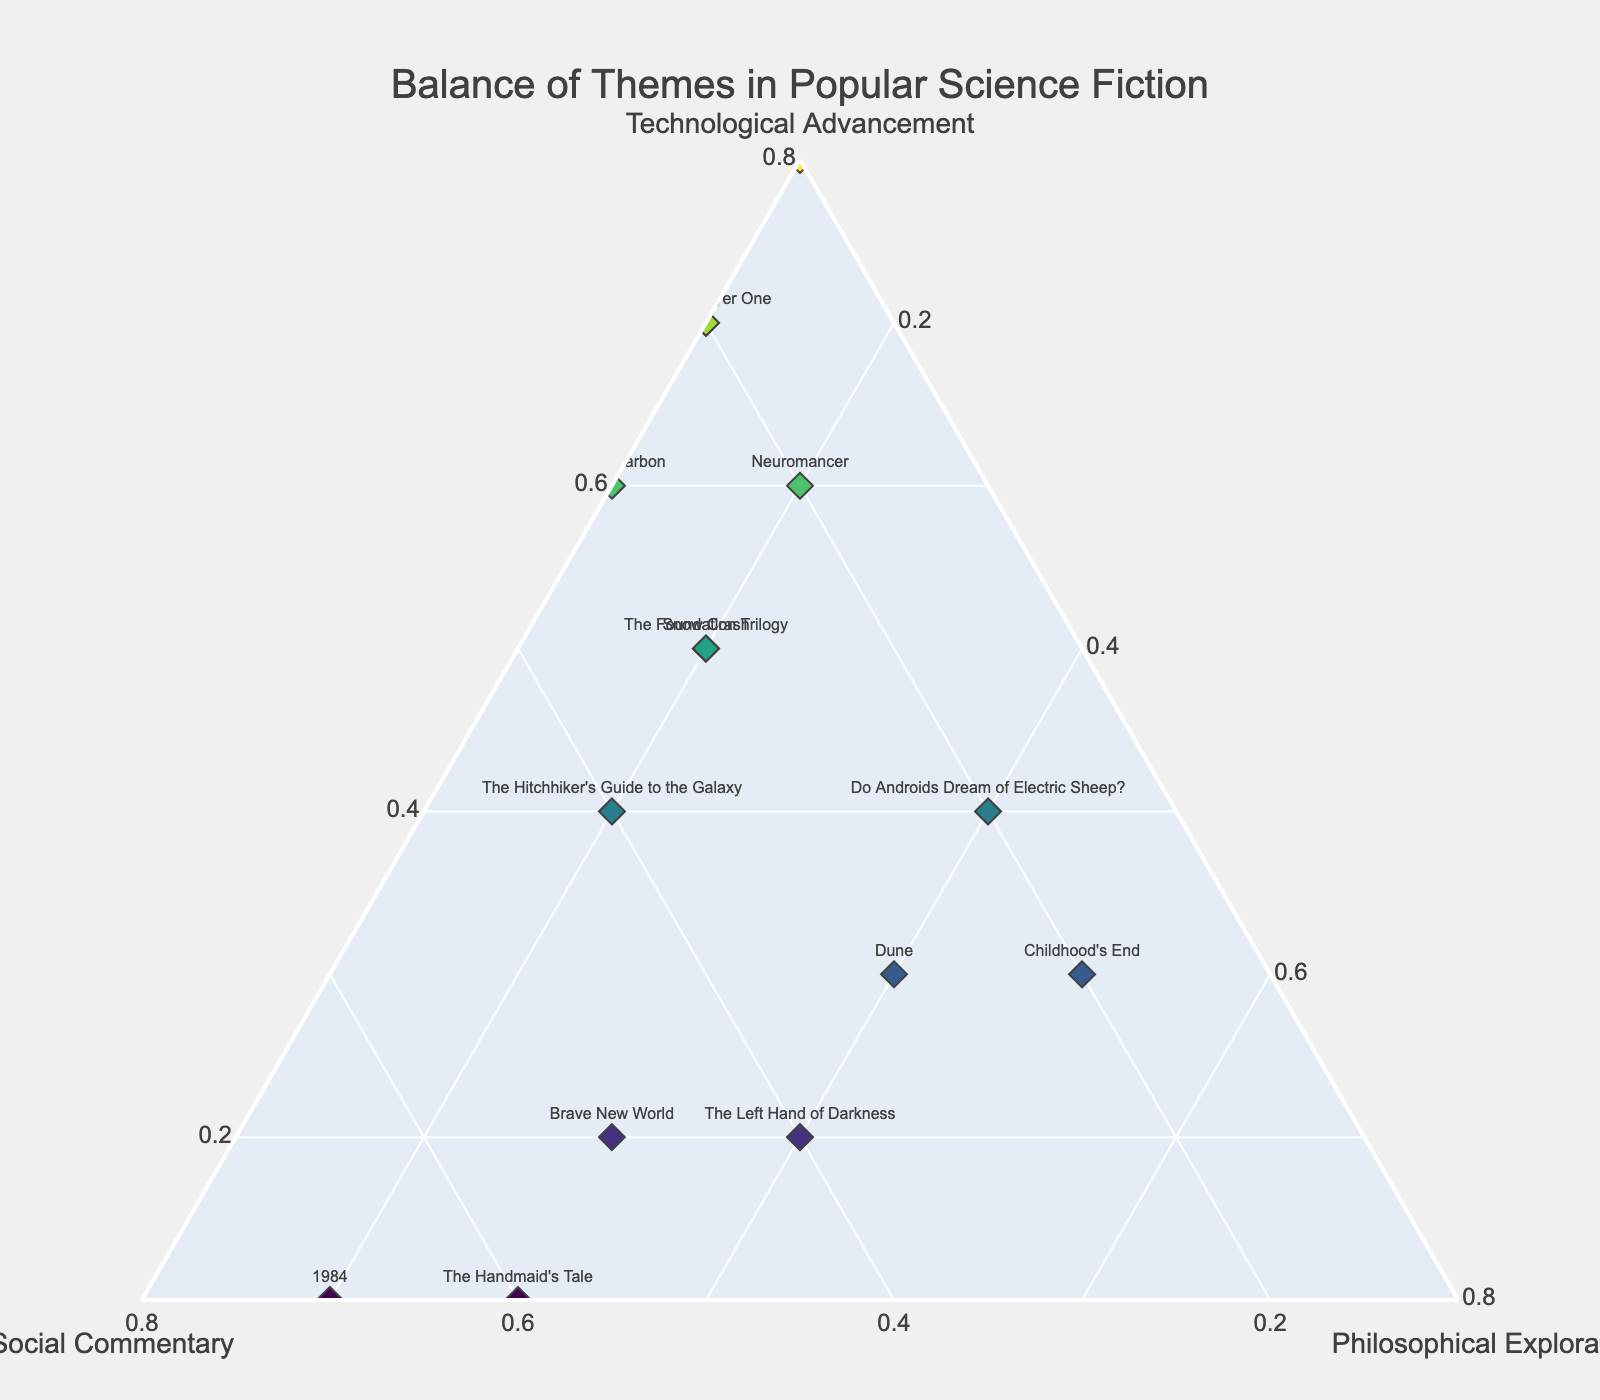How many science fiction novels are represented in the plot? Count the number of unique titles in the legend or points in the plot.
Answer: 14 Which novel has the highest emphasis on Technological Advancement? Look for the data point closest to the Technological Advancement corner, which is represented by "The Martian."
Answer: The Martian Which novels have an equal emphasis on Philosophical Exploration and Social Commentary? Identify data points plotted on a line halfway between the Philosophical Exploration and Social Commentary axes. These are "Dune" and "The Left Hand of Darkness."
Answer: Dune, The Left Hand of Darkness Which theme is least represented in "Ready Player One"? Check the coordinates of "Ready Player One" and find the smallest value. It is "Philosophical Exploration" with a value of 0.1.
Answer: Philosophical Exploration What is the combined total of Social Commentary and Philosophical Exploration in "Neuromancer"? Sum the values of Social Commentary (0.2) and Philosophical Exploration (0.2) for "Neuromancer."
Answer: 0.4 Which novel has a nearly equal balance of all three themes? Identify the data point closest to the center of the ternary plot. "The Hitchhiker's Guide to the Galaxy" has ratios of 0.4, 0.4, and 0.2.
Answer: The Hitchhiker's Guide to the Galaxy Which novels have a higher emphasis on Social Commentary than Technological Advancement? Compare the Social Commentary values with Technological Advancement values. They are "1984," "Brave New World," "The Handmaid's Tale," and "The Hitchhiker's Guide to the Galaxy."
Answer: 1984, Brave New World, The Handmaid's Tale, The Hitchhiker's Guide to the Galaxy What is the average value of Technological Advancement for all the listed novels? Sum all Technological Advancement values and divide by the number of novels (14). (0.6+0.3+0.4+0.1+0.2+0.5+0.5+0.3+0.2+0.4+0.1+0.7+0.8+0.6)/14 = 0.414
Answer: 0.414 Which novel has coordinates of 0.1 for two themes? Look for the novel with coordinates where two values are 0.1. "The Martian" has 0.1 for Social Commentary and Philosophical Exploration.
Answer: The Martian 